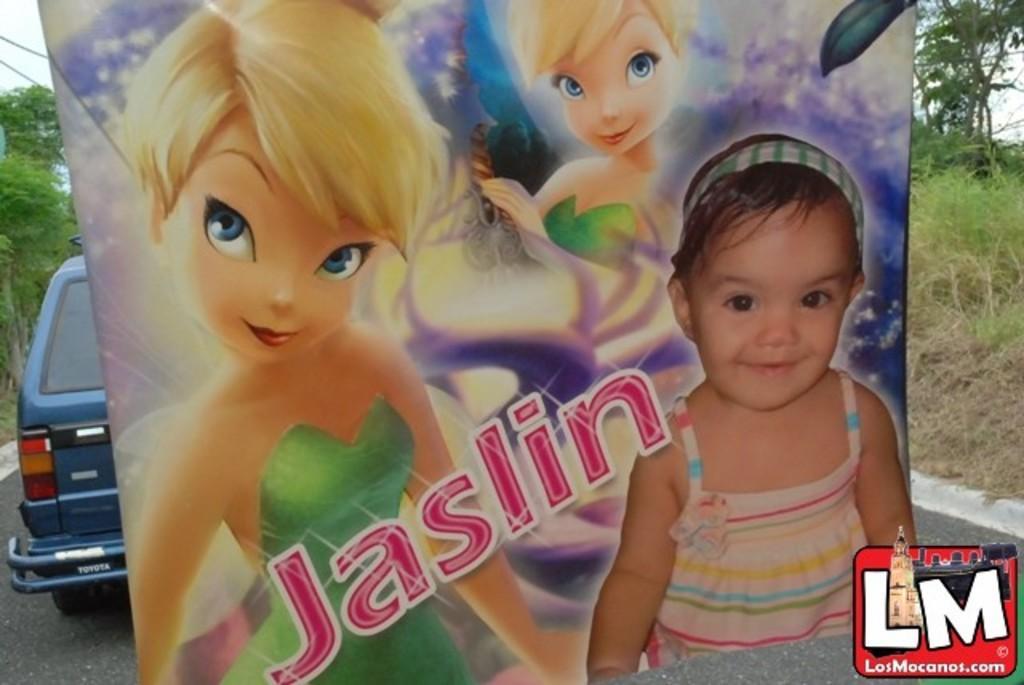Describe this image in one or two sentences. In the foreground of the picture there is a banner, in the banner there are animated pictures and a girls picture. In the center there is text. On the right there are trees, plants, grass, soil and road. On the left there are trees, car and road. 